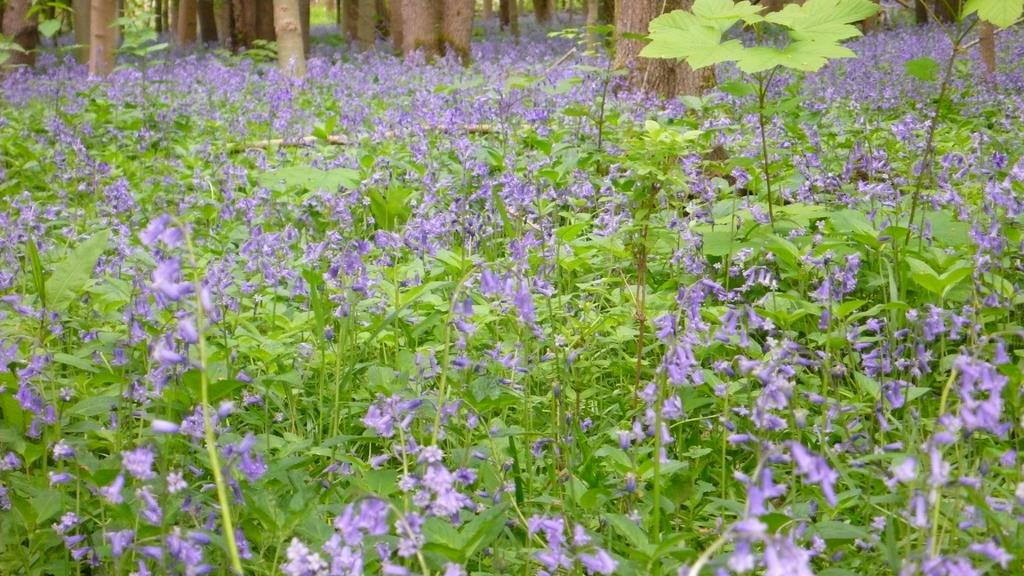What type of plants are present in the image? There is a group of plants with flowers in the image. Can you describe any other features of the plants? Unfortunately, the provided facts do not mention any other features of the plants. What can be seen on the backside of the image? The bark of trees is visible on the backside of the image. How many types of plants are visible in the image? The provided facts only mention a group of plants with flowers, so we cannot determine the exact number of plant types. What is the daughter of the maid doing in the image? There is no mention of a daughter or a maid in the provided facts, so we cannot answer this question. 